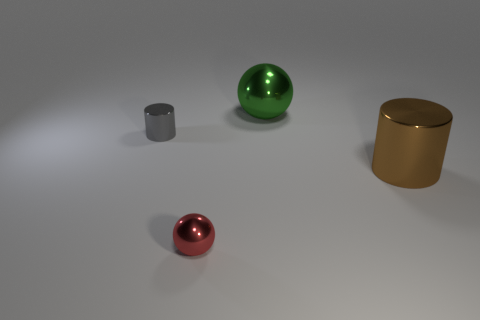Add 1 yellow rubber spheres. How many objects exist? 5 Subtract all big green spheres. Subtract all brown cylinders. How many objects are left? 2 Add 3 large brown metallic cylinders. How many large brown metallic cylinders are left? 4 Add 3 rubber cylinders. How many rubber cylinders exist? 3 Subtract 0 cyan cubes. How many objects are left? 4 